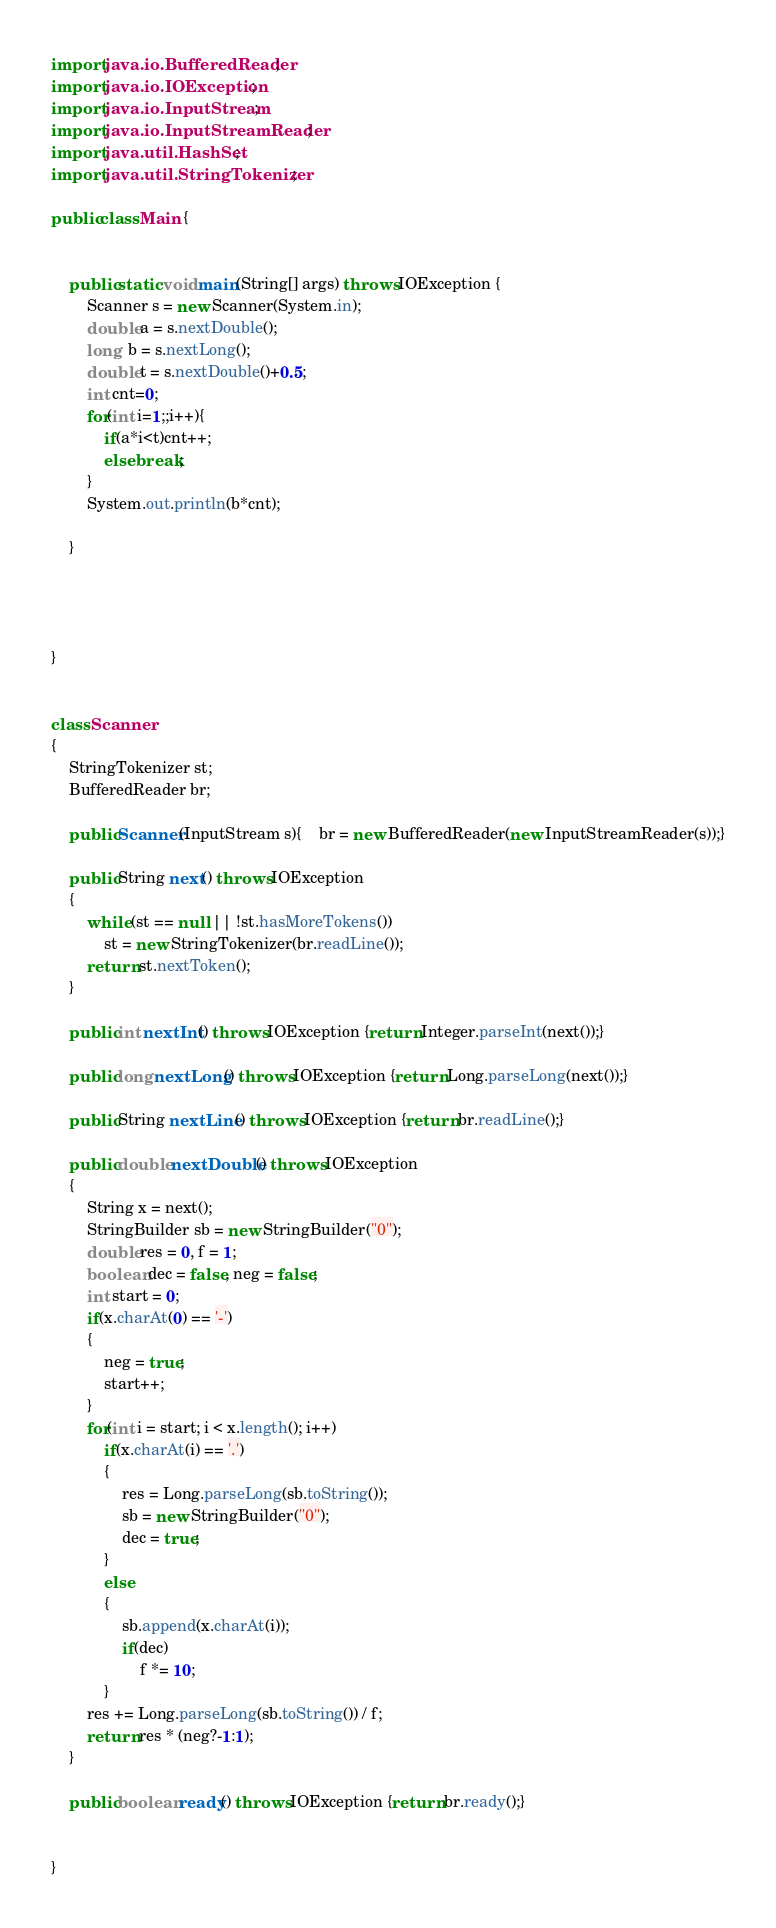Convert code to text. <code><loc_0><loc_0><loc_500><loc_500><_Java_>
import java.io.BufferedReader;
import java.io.IOException;
import java.io.InputStream;
import java.io.InputStreamReader;
import java.util.HashSet;
import java.util.StringTokenizer;

public class Main {


    public static void main(String[] args) throws IOException {
        Scanner s = new Scanner(System.in);
        double a = s.nextDouble();
        long  b = s.nextLong();
        double t = s.nextDouble()+0.5;
        int cnt=0;
        for(int i=1;;i++){
            if(a*i<t)cnt++;
            else break;
        }
        System.out.println(b*cnt);

    }




}


class Scanner
{
    StringTokenizer st;
    BufferedReader br;

    public Scanner(InputStream s){	br = new BufferedReader(new InputStreamReader(s));}

    public String next() throws IOException
    {
        while (st == null || !st.hasMoreTokens())
            st = new StringTokenizer(br.readLine());
        return st.nextToken();
    }

    public int nextInt() throws IOException {return Integer.parseInt(next());}

    public long nextLong() throws IOException {return Long.parseLong(next());}

    public String nextLine() throws IOException {return br.readLine();}

    public double nextDouble() throws IOException
    {
        String x = next();
        StringBuilder sb = new StringBuilder("0");
        double res = 0, f = 1;
        boolean dec = false, neg = false;
        int start = 0;
        if(x.charAt(0) == '-')
        {
            neg = true;
            start++;
        }
        for(int i = start; i < x.length(); i++)
            if(x.charAt(i) == '.')
            {
                res = Long.parseLong(sb.toString());
                sb = new StringBuilder("0");
                dec = true;
            }
            else
            {
                sb.append(x.charAt(i));
                if(dec)
                    f *= 10;
            }
        res += Long.parseLong(sb.toString()) / f;
        return res * (neg?-1:1);
    }

    public boolean ready() throws IOException {return br.ready();}


}</code> 